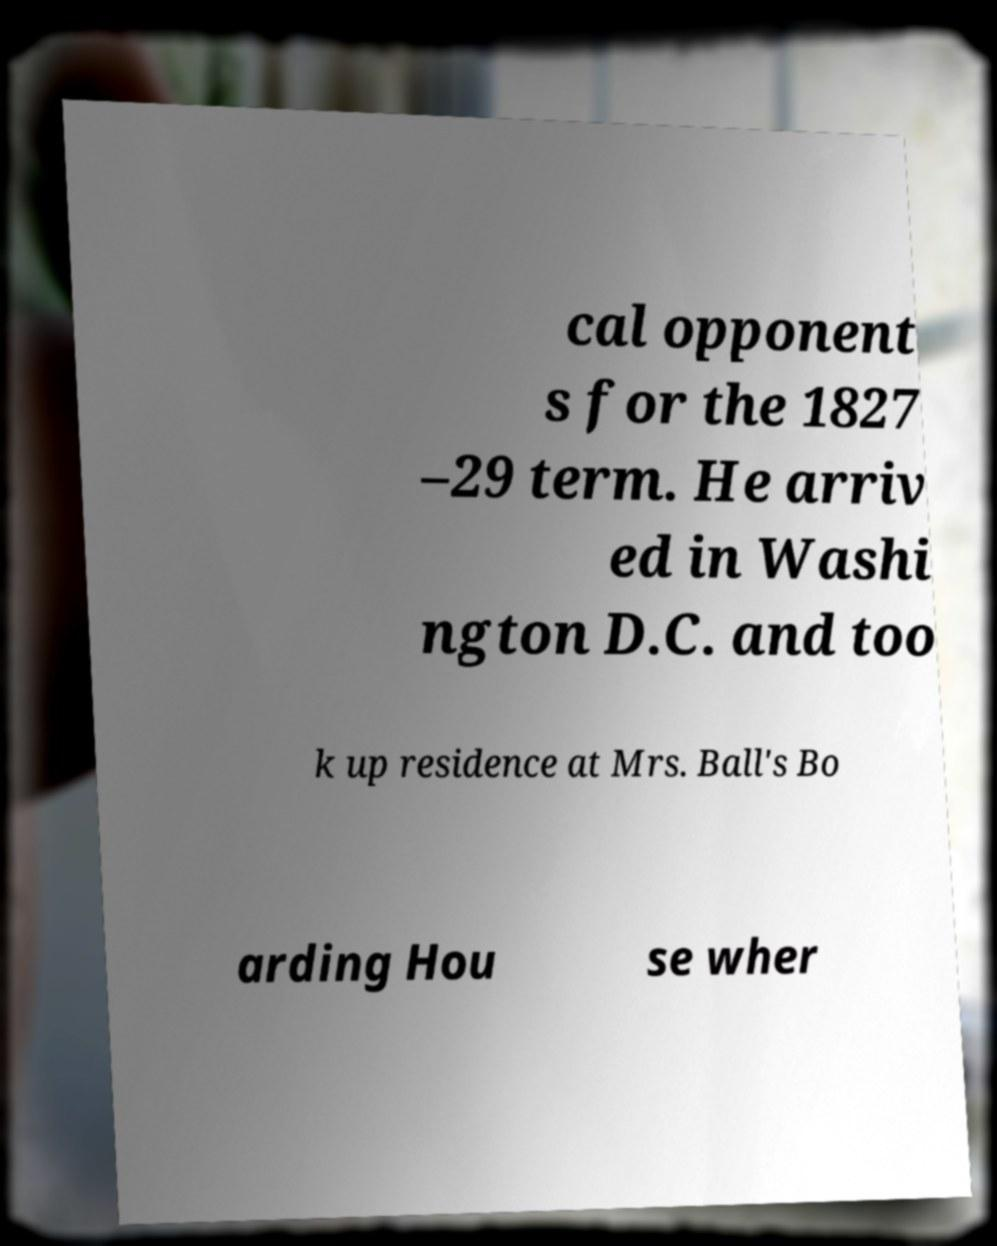Please read and relay the text visible in this image. What does it say? cal opponent s for the 1827 –29 term. He arriv ed in Washi ngton D.C. and too k up residence at Mrs. Ball's Bo arding Hou se wher 